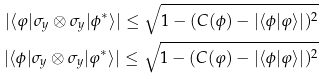<formula> <loc_0><loc_0><loc_500><loc_500>| \langle \varphi | \sigma _ { y } \otimes \sigma _ { y } | \phi ^ { * } \rangle | \leq \sqrt { 1 - ( C ( \phi ) - | \langle \phi | \varphi \rangle | ) ^ { 2 } } \\ | \langle \phi | \sigma _ { y } \otimes \sigma _ { y } | \varphi ^ { * } \rangle | \leq \sqrt { 1 - ( C ( \varphi ) - | \langle \phi | \varphi \rangle | ) ^ { 2 } }</formula> 